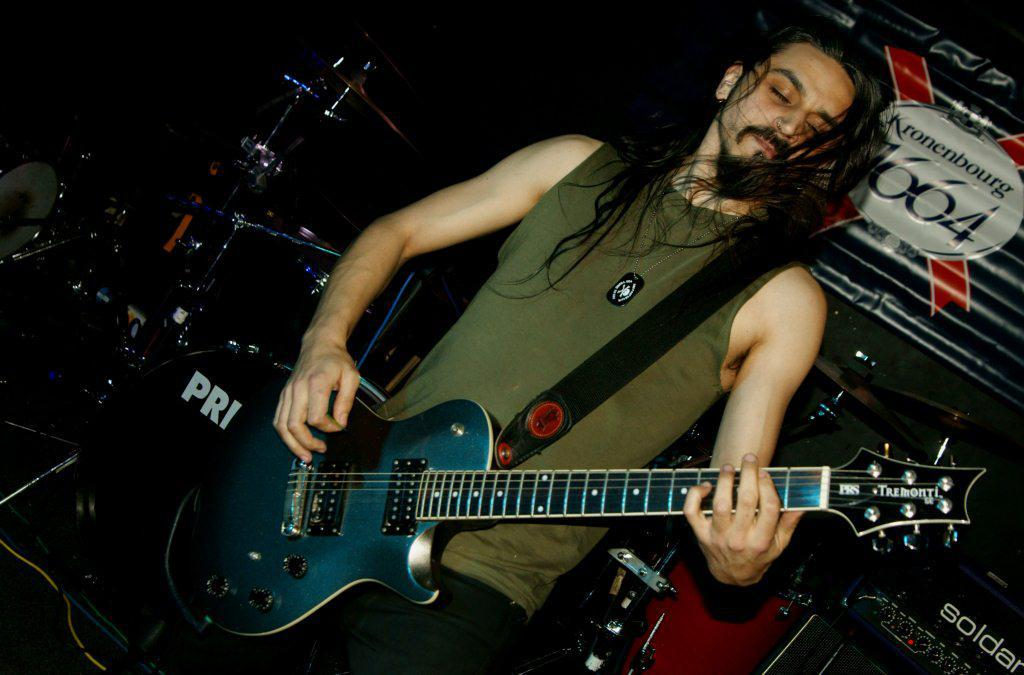What is the man in the image doing? The man is playing the guitar. What is the man wearing in the image? The man is wearing a t-shirt. What else can be seen around the man in the image? There are musical instruments around the man. What type of grass is growing on the man's legs in the image? There is no grass growing on the man's legs in the image, as he is wearing a t-shirt and not exposed to any grass. 